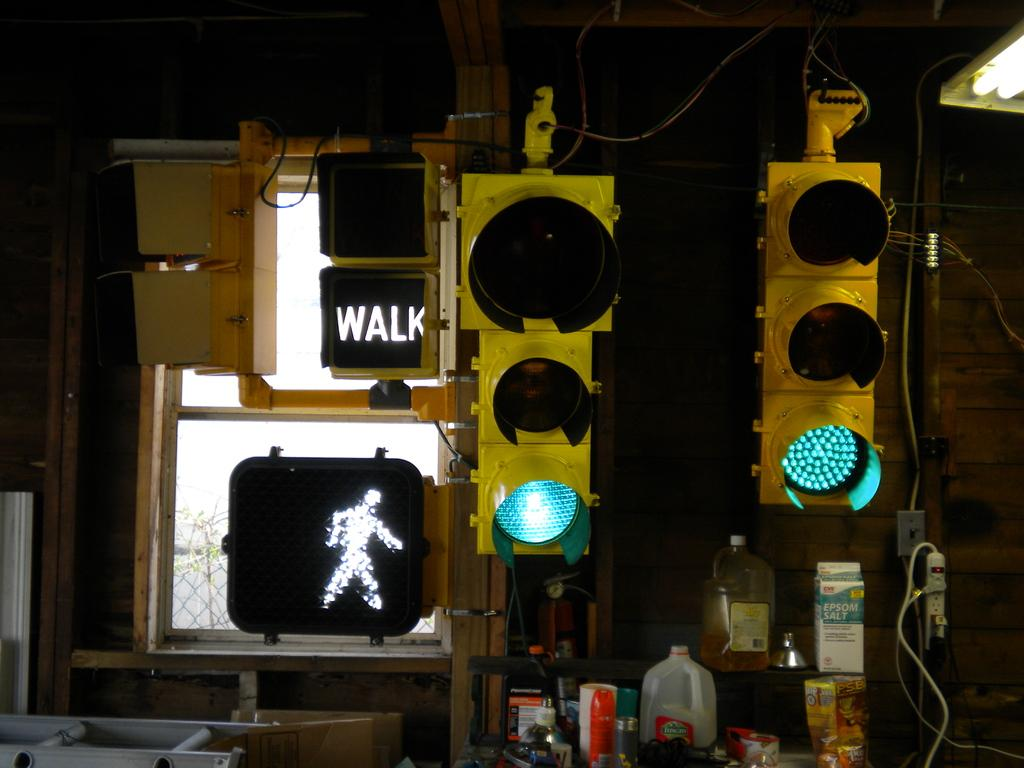<image>
Present a compact description of the photo's key features. Traffic lights, including a pedestrian crossing light reading WALK, inside a structure with a window. 